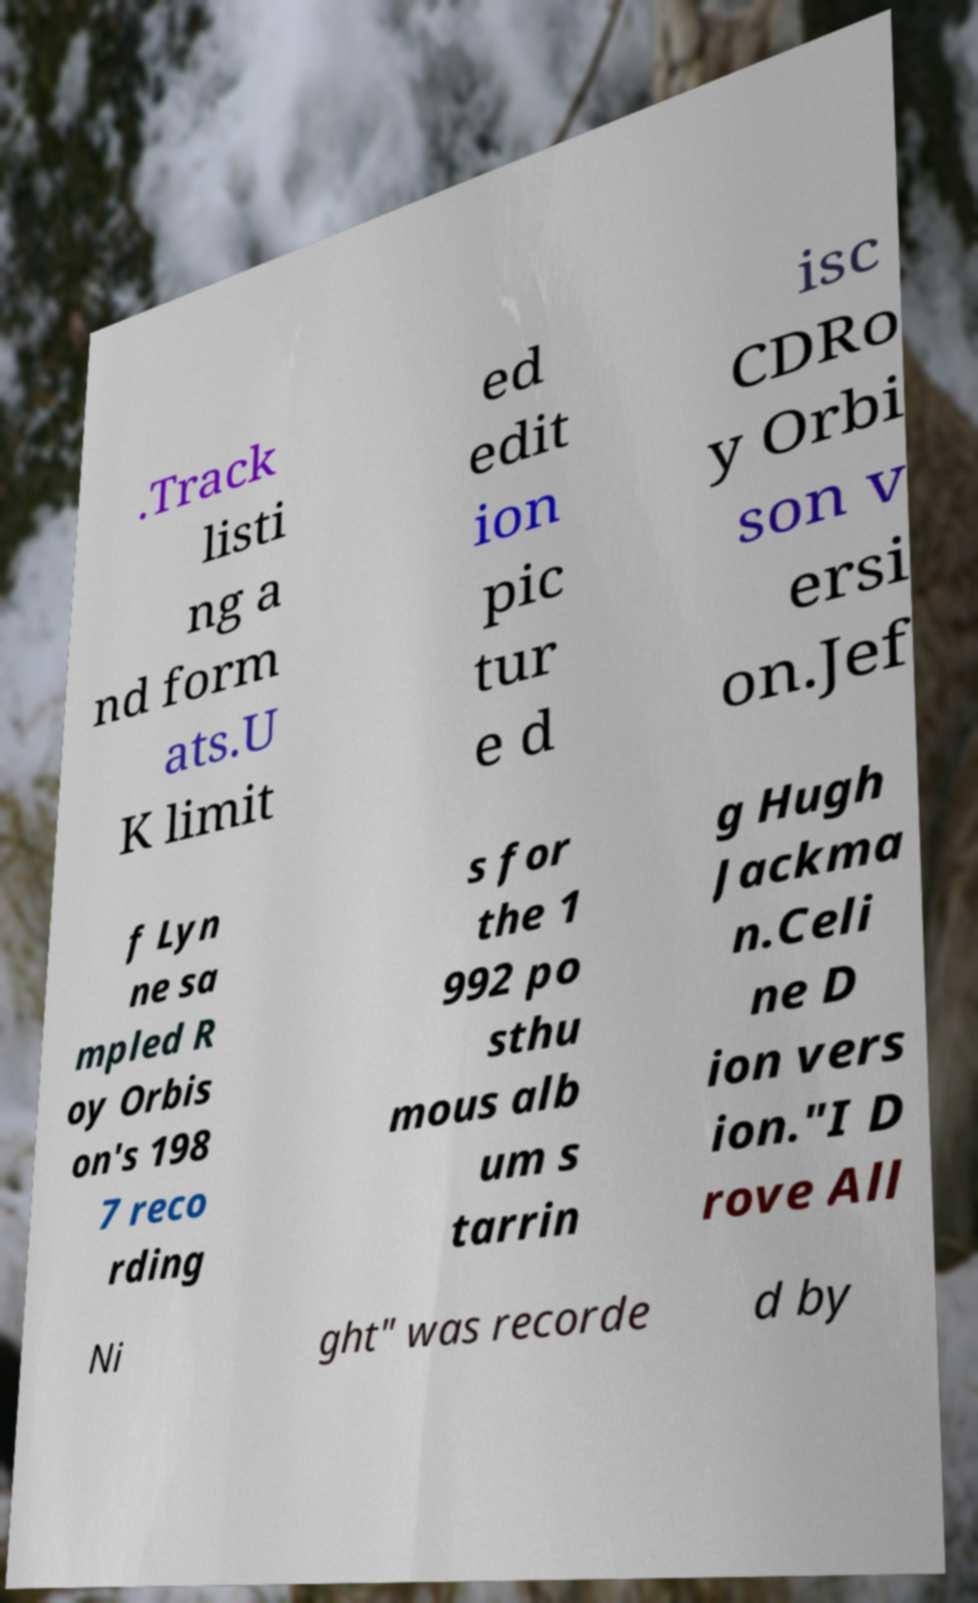Could you assist in decoding the text presented in this image and type it out clearly? .Track listi ng a nd form ats.U K limit ed edit ion pic tur e d isc CDRo y Orbi son v ersi on.Jef f Lyn ne sa mpled R oy Orbis on's 198 7 reco rding s for the 1 992 po sthu mous alb um s tarrin g Hugh Jackma n.Celi ne D ion vers ion."I D rove All Ni ght" was recorde d by 